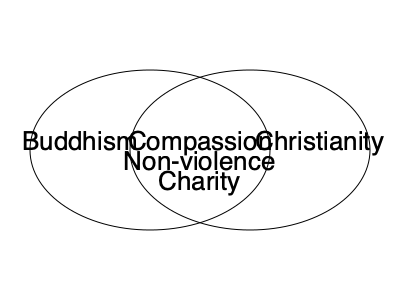Analyze the Venn diagram depicting the ethical principles shared by Buddhism and Christianity. Which fundamental ethical concept, not explicitly shown, could be added to the intersection to further illustrate the commonality between these two major world religions? To answer this question, we need to consider the following steps:

1. Examine the existing shared principles:
   - Compassion
   - Non-violence
   - Charity

2. Reflect on other core ethical teachings in both Buddhism and Christianity:
   - Buddhism emphasizes the Four Noble Truths and the Eightfold Path
   - Christianity is centered around the teachings of Jesus Christ and the Ten Commandments

3. Identify a principle that is fundamental to both religions but not yet represented:
   - Both religions emphasize the importance of moral behavior and ethical conduct
   - They both teach the concept of treating others with respect and dignity

4. Consider the Golden Rule:
   - In Buddhism: "Hurt not others in ways that you yourself would find hurtful" (Udana-Varga 5:18)
   - In Christianity: "Do unto others as you would have them do unto you" (Matthew 7:12)

5. Recognize that the Golden Rule, or the principle of reciprocity, is a fundamental ethical concept shared by both religions and many others worldwide

6. Conclude that the Golden Rule could be added to the intersection of the Venn diagram to further illustrate the ethical commonality between Buddhism and Christianity
Answer: The Golden Rule 